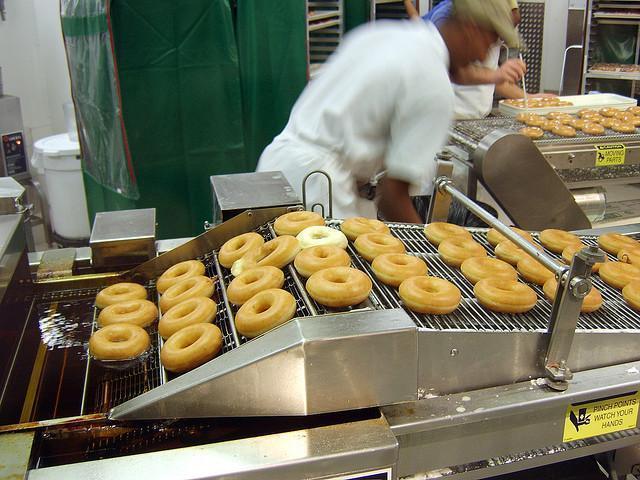What type of job are the men doing?
Pick the correct solution from the four options below to address the question.
Options: Paving, dancing, construction, baking. Baking. 